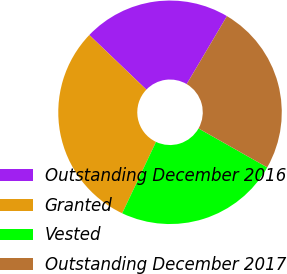Convert chart. <chart><loc_0><loc_0><loc_500><loc_500><pie_chart><fcel>Outstanding December 2016<fcel>Granted<fcel>Vested<fcel>Outstanding December 2017<nl><fcel>21.35%<fcel>30.12%<fcel>23.83%<fcel>24.7%<nl></chart> 